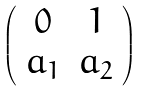Convert formula to latex. <formula><loc_0><loc_0><loc_500><loc_500>\left ( \begin{array} { c c } 0 & 1 \\ a _ { 1 } & a _ { 2 } \end{array} \right )</formula> 